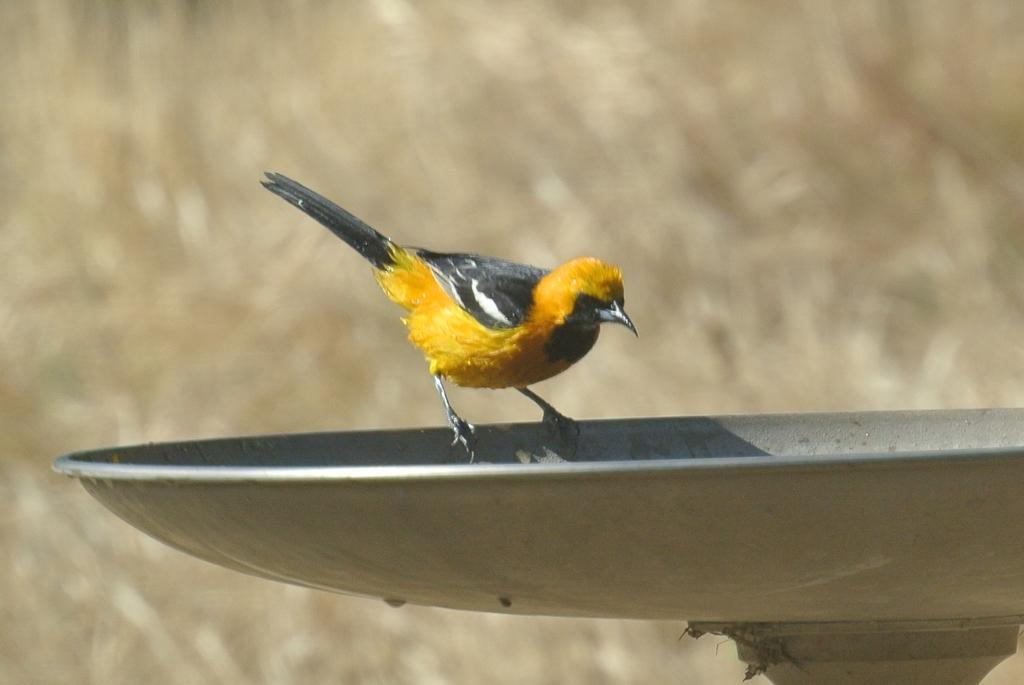What is located in the foreground of the picture? There is a beaker and a bird in the foreground of the picture. Can you describe the background of the image? The background of the image is blurred. How many girls are visible on the map in the image? There is no map present in the image, so it is not possible to determine how many girls might be visible on it. 